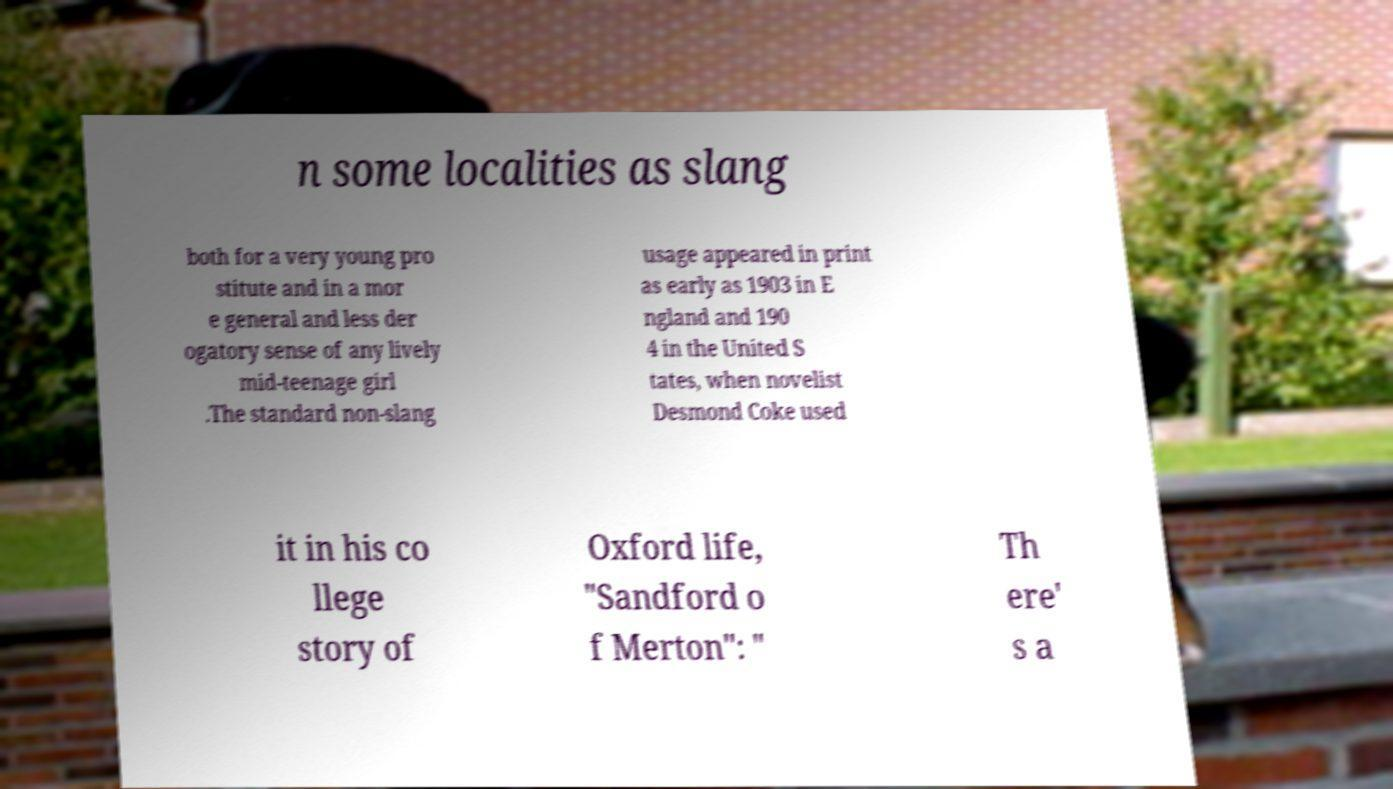Could you assist in decoding the text presented in this image and type it out clearly? n some localities as slang both for a very young pro stitute and in a mor e general and less der ogatory sense of any lively mid-teenage girl .The standard non-slang usage appeared in print as early as 1903 in E ngland and 190 4 in the United S tates, when novelist Desmond Coke used it in his co llege story of Oxford life, "Sandford o f Merton": " Th ere' s a 